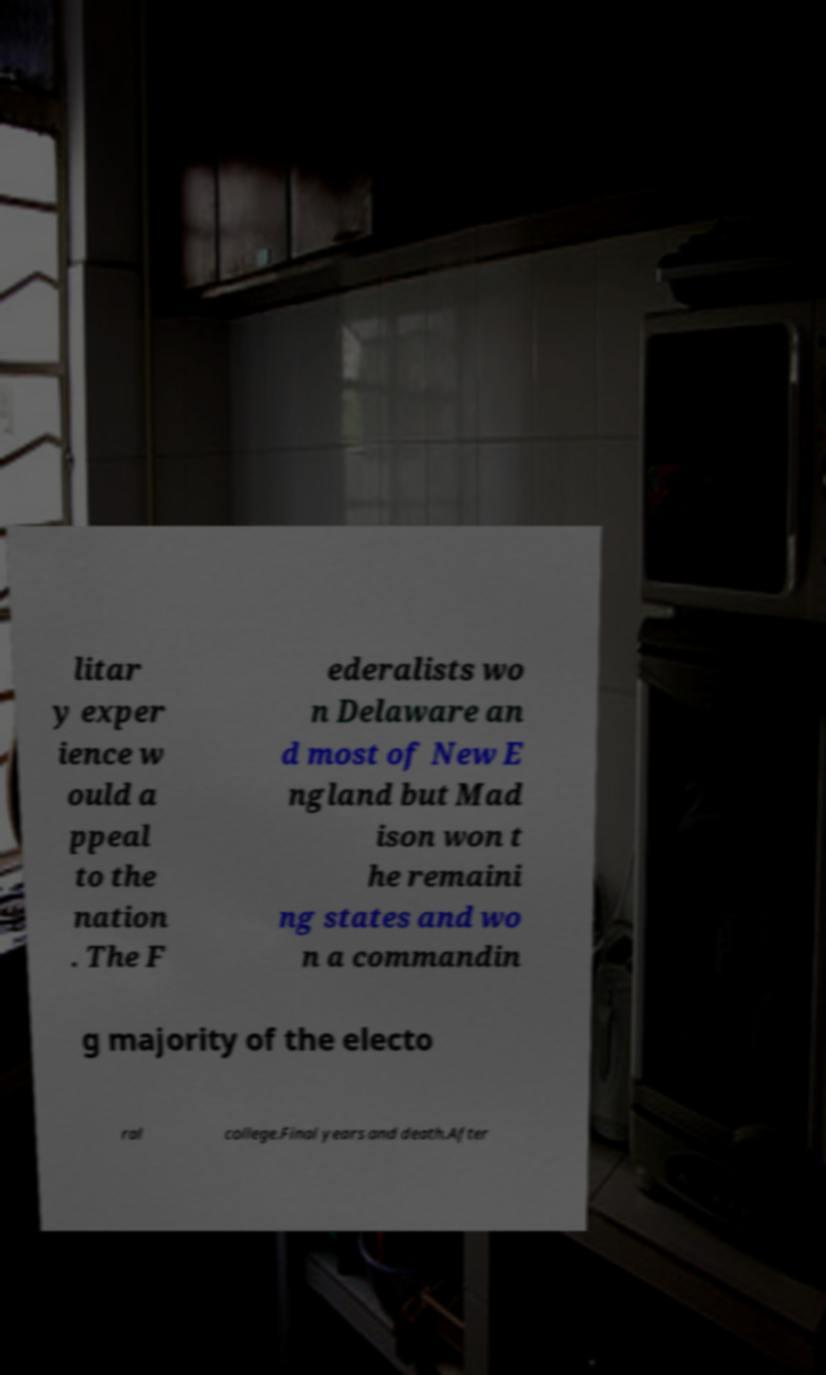Can you read and provide the text displayed in the image?This photo seems to have some interesting text. Can you extract and type it out for me? litar y exper ience w ould a ppeal to the nation . The F ederalists wo n Delaware an d most of New E ngland but Mad ison won t he remaini ng states and wo n a commandin g majority of the electo ral college.Final years and death.After 